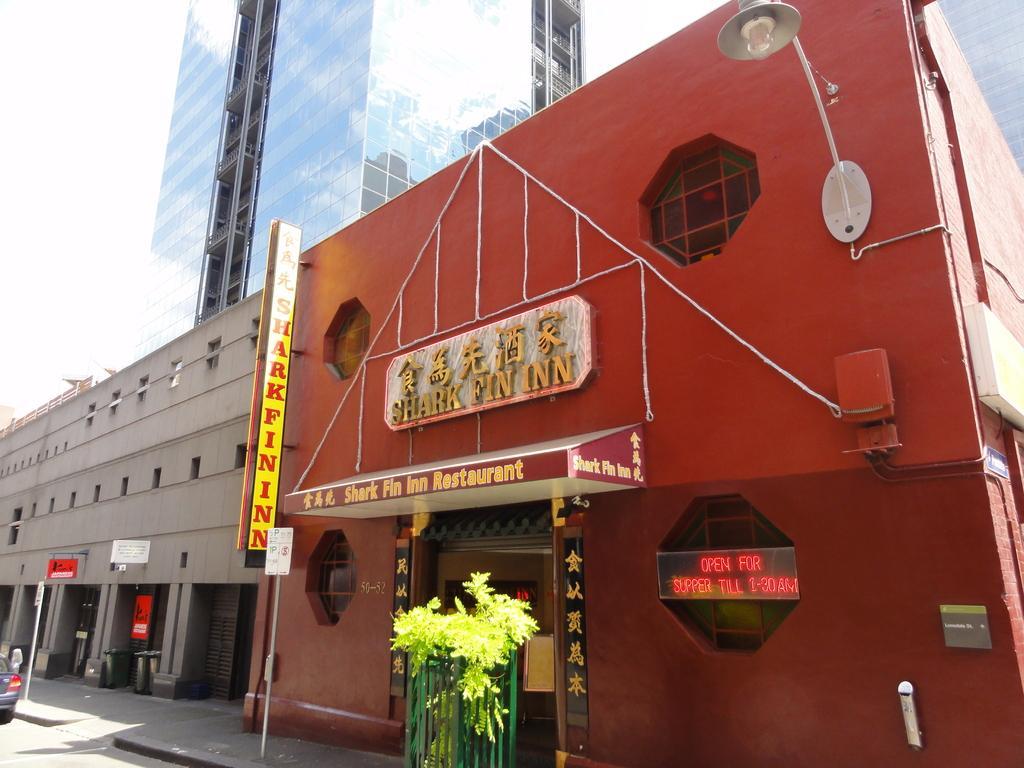Could you give a brief overview of what you see in this image? In this picture I can see there are some buildings and there is a car parked here on the road and the sky is clear. 